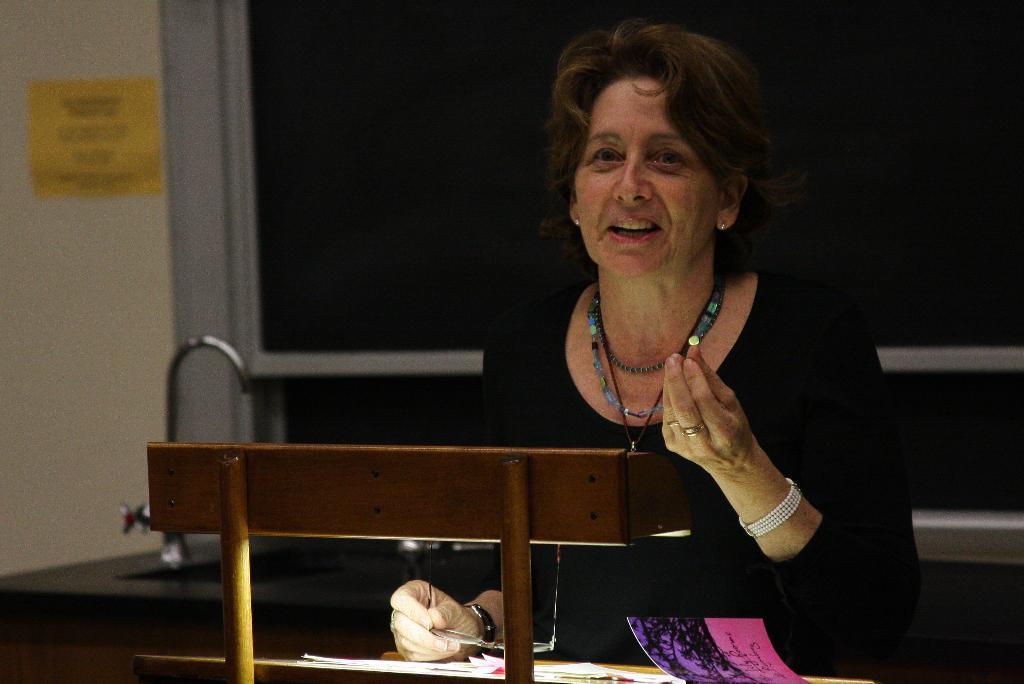Could you give a brief overview of what you see in this image? There is a lady wearing chains, watch, rings, bracelet is holding a specs. In front of her there is a table with books. In the back there is a platform with sink and tap. Also there is a wall with something on that. 